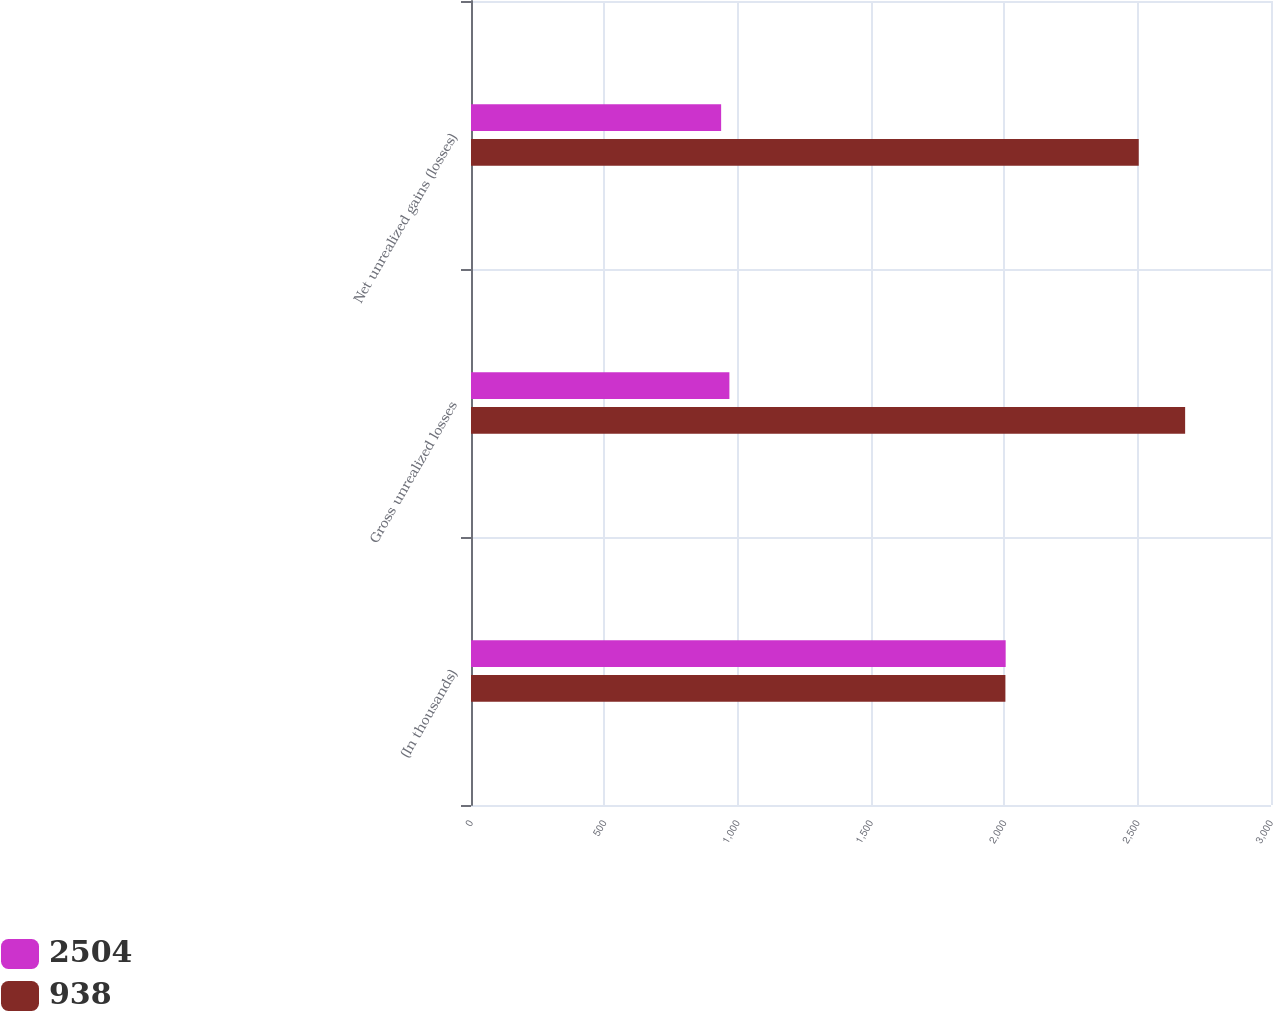Convert chart. <chart><loc_0><loc_0><loc_500><loc_500><stacked_bar_chart><ecel><fcel>(In thousands)<fcel>Gross unrealized losses<fcel>Net unrealized gains (losses)<nl><fcel>2504<fcel>2005<fcel>969<fcel>938<nl><fcel>938<fcel>2004<fcel>2678<fcel>2504<nl></chart> 